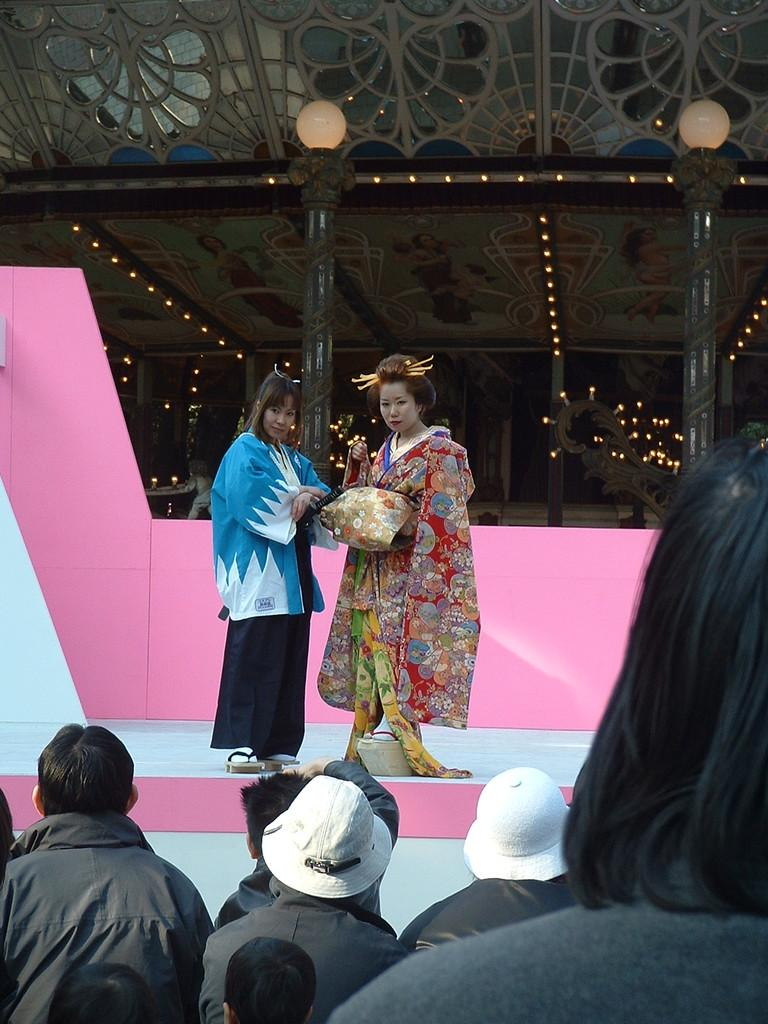Who or what is present in the image? There are people in the image. What are the people wearing? The people are wearing clothes. What can be seen in the middle of the image? There are poles and lights in the middle of the image. What type of instrument is being played in the image? There is no instrument present in the image. Where is the office located in the image? There is no office present in the image. 